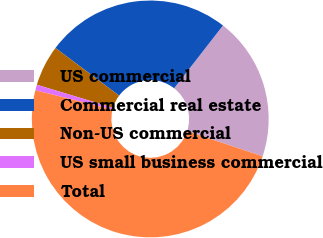Convert chart. <chart><loc_0><loc_0><loc_500><loc_500><pie_chart><fcel>US commercial<fcel>Commercial real estate<fcel>Non-US commercial<fcel>US small business commercial<fcel>Total<nl><fcel>19.58%<fcel>25.3%<fcel>5.57%<fcel>0.77%<fcel>48.78%<nl></chart> 